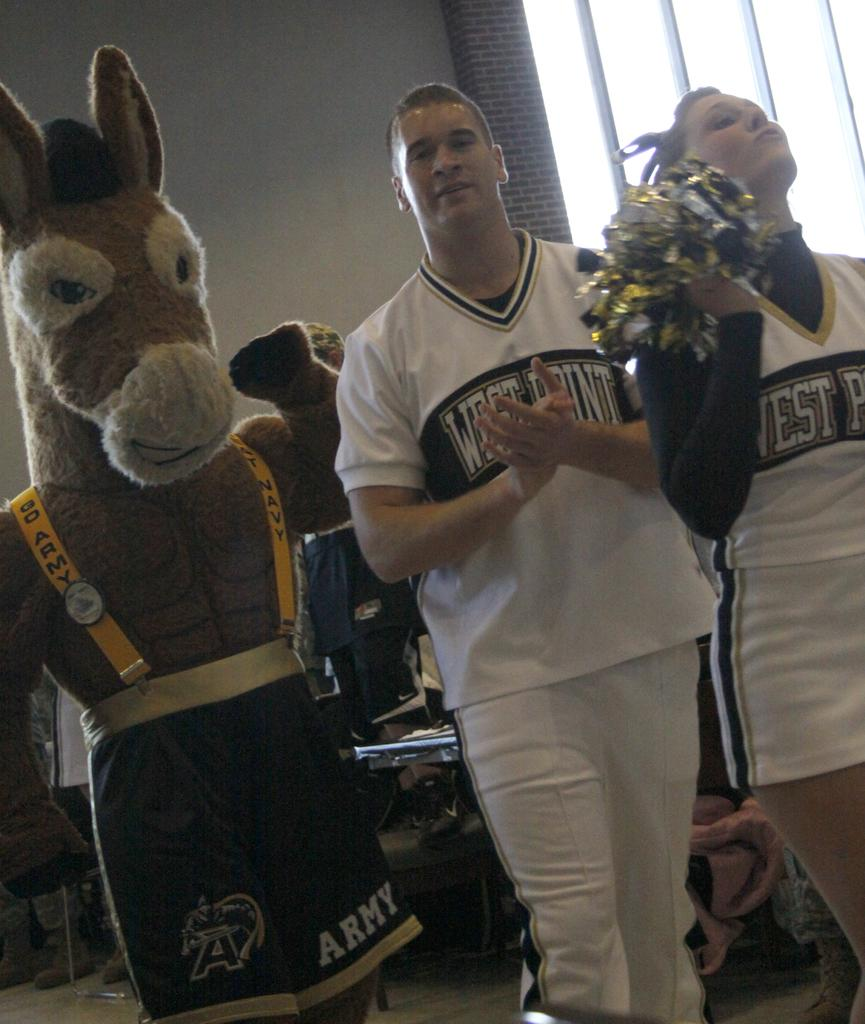Provide a one-sentence caption for the provided image. A man and woman in West Point shirts next to a donkey mascot. 